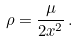<formula> <loc_0><loc_0><loc_500><loc_500>\rho = \frac { \mu } { 2 x ^ { 2 } } \, .</formula> 